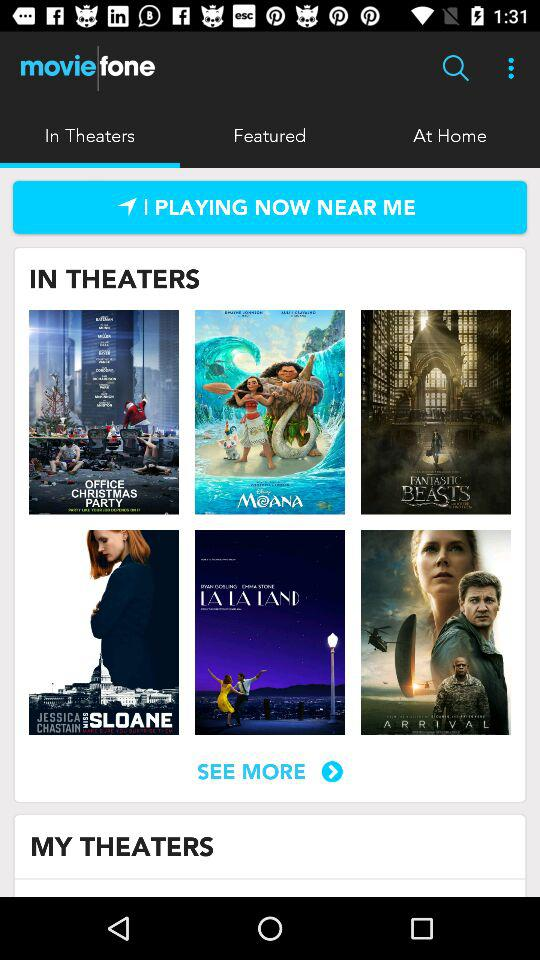What is the application name? The application name is "moviefone". 